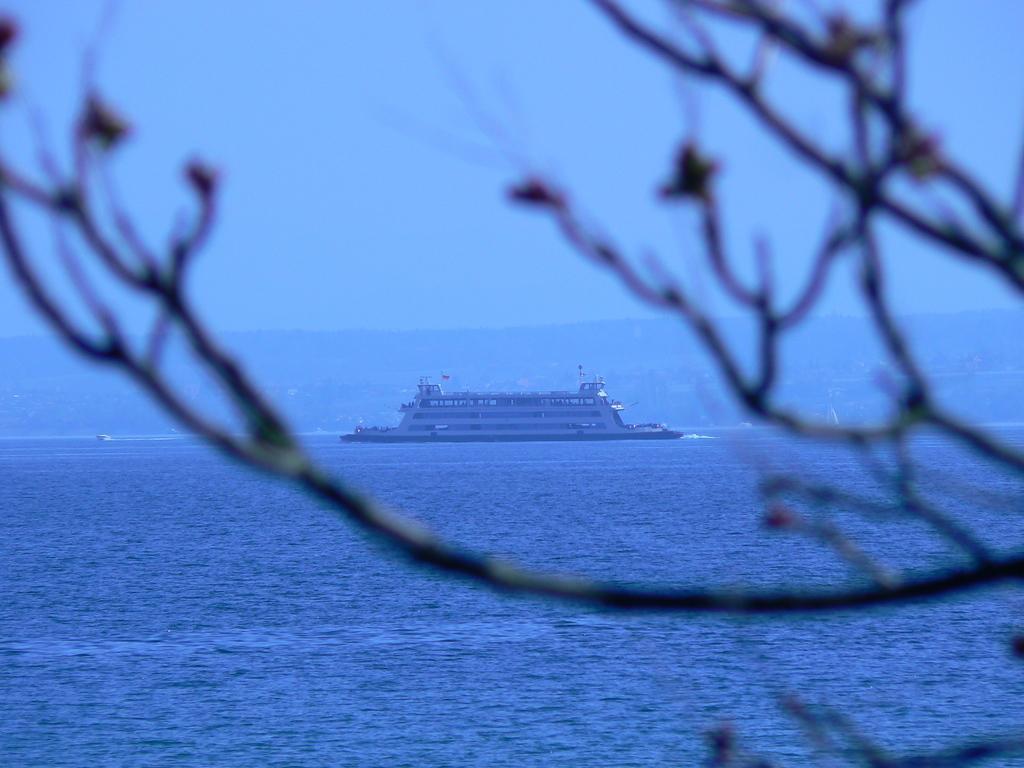Describe this image in one or two sentences. In this picture there is a huge ship in the center of the image, on the water and there is trees in the image. 